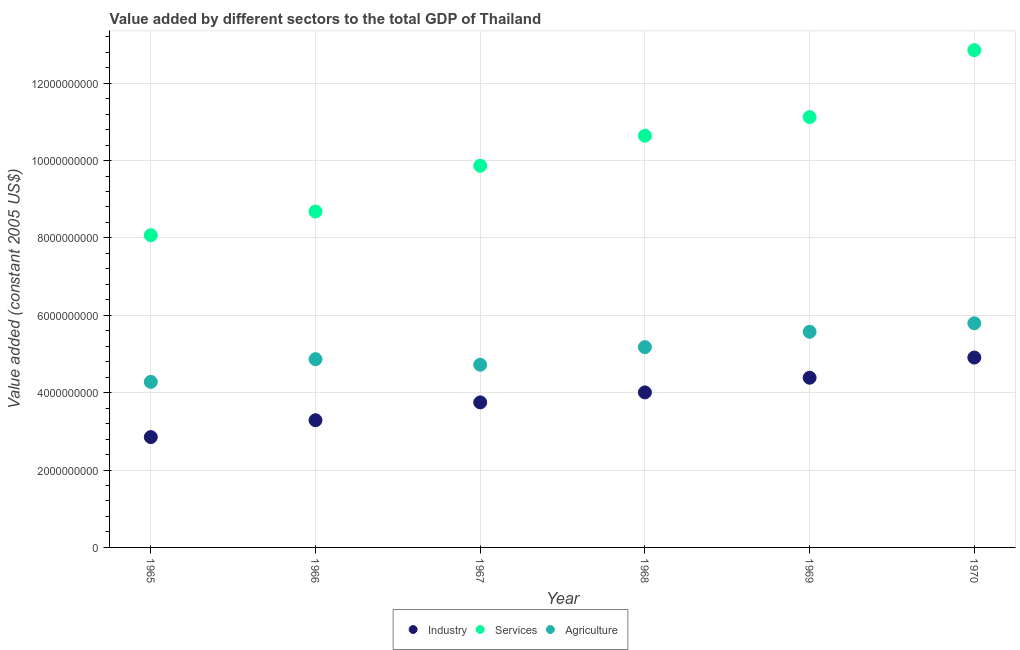How many different coloured dotlines are there?
Give a very brief answer. 3. What is the value added by services in 1967?
Your answer should be compact. 9.87e+09. Across all years, what is the maximum value added by industrial sector?
Provide a short and direct response. 4.91e+09. Across all years, what is the minimum value added by services?
Keep it short and to the point. 8.07e+09. In which year was the value added by industrial sector minimum?
Provide a short and direct response. 1965. What is the total value added by services in the graph?
Offer a very short reply. 6.12e+1. What is the difference between the value added by services in 1965 and that in 1969?
Keep it short and to the point. -3.05e+09. What is the difference between the value added by services in 1966 and the value added by industrial sector in 1969?
Make the answer very short. 4.30e+09. What is the average value added by industrial sector per year?
Offer a terse response. 3.86e+09. In the year 1969, what is the difference between the value added by industrial sector and value added by services?
Make the answer very short. -6.74e+09. What is the ratio of the value added by services in 1966 to that in 1970?
Provide a short and direct response. 0.68. Is the value added by industrial sector in 1965 less than that in 1970?
Offer a very short reply. Yes. Is the difference between the value added by services in 1966 and 1967 greater than the difference between the value added by industrial sector in 1966 and 1967?
Keep it short and to the point. No. What is the difference between the highest and the second highest value added by industrial sector?
Make the answer very short. 5.22e+08. What is the difference between the highest and the lowest value added by agricultural sector?
Make the answer very short. 1.52e+09. Does the value added by industrial sector monotonically increase over the years?
Your response must be concise. Yes. Is the value added by agricultural sector strictly greater than the value added by services over the years?
Your answer should be compact. No. Is the value added by services strictly less than the value added by industrial sector over the years?
Ensure brevity in your answer.  No. How many dotlines are there?
Provide a short and direct response. 3. Does the graph contain any zero values?
Your response must be concise. No. How many legend labels are there?
Make the answer very short. 3. How are the legend labels stacked?
Keep it short and to the point. Horizontal. What is the title of the graph?
Your answer should be very brief. Value added by different sectors to the total GDP of Thailand. Does "Textiles and clothing" appear as one of the legend labels in the graph?
Offer a very short reply. No. What is the label or title of the X-axis?
Your answer should be very brief. Year. What is the label or title of the Y-axis?
Provide a succinct answer. Value added (constant 2005 US$). What is the Value added (constant 2005 US$) in Industry in 1965?
Your answer should be compact. 2.85e+09. What is the Value added (constant 2005 US$) of Services in 1965?
Offer a terse response. 8.07e+09. What is the Value added (constant 2005 US$) in Agriculture in 1965?
Your answer should be compact. 4.28e+09. What is the Value added (constant 2005 US$) in Industry in 1966?
Your answer should be very brief. 3.29e+09. What is the Value added (constant 2005 US$) in Services in 1966?
Your answer should be very brief. 8.68e+09. What is the Value added (constant 2005 US$) of Agriculture in 1966?
Keep it short and to the point. 4.87e+09. What is the Value added (constant 2005 US$) of Industry in 1967?
Your response must be concise. 3.75e+09. What is the Value added (constant 2005 US$) of Services in 1967?
Ensure brevity in your answer.  9.87e+09. What is the Value added (constant 2005 US$) in Agriculture in 1967?
Offer a terse response. 4.72e+09. What is the Value added (constant 2005 US$) in Industry in 1968?
Offer a very short reply. 4.01e+09. What is the Value added (constant 2005 US$) in Services in 1968?
Your answer should be very brief. 1.06e+1. What is the Value added (constant 2005 US$) of Agriculture in 1968?
Your answer should be compact. 5.18e+09. What is the Value added (constant 2005 US$) of Industry in 1969?
Ensure brevity in your answer.  4.39e+09. What is the Value added (constant 2005 US$) of Services in 1969?
Your answer should be very brief. 1.11e+1. What is the Value added (constant 2005 US$) in Agriculture in 1969?
Your response must be concise. 5.57e+09. What is the Value added (constant 2005 US$) in Industry in 1970?
Provide a succinct answer. 4.91e+09. What is the Value added (constant 2005 US$) in Services in 1970?
Your answer should be compact. 1.29e+1. What is the Value added (constant 2005 US$) of Agriculture in 1970?
Give a very brief answer. 5.79e+09. Across all years, what is the maximum Value added (constant 2005 US$) in Industry?
Your response must be concise. 4.91e+09. Across all years, what is the maximum Value added (constant 2005 US$) in Services?
Your answer should be compact. 1.29e+1. Across all years, what is the maximum Value added (constant 2005 US$) of Agriculture?
Your response must be concise. 5.79e+09. Across all years, what is the minimum Value added (constant 2005 US$) of Industry?
Ensure brevity in your answer.  2.85e+09. Across all years, what is the minimum Value added (constant 2005 US$) of Services?
Provide a short and direct response. 8.07e+09. Across all years, what is the minimum Value added (constant 2005 US$) of Agriculture?
Provide a short and direct response. 4.28e+09. What is the total Value added (constant 2005 US$) in Industry in the graph?
Your answer should be compact. 2.32e+1. What is the total Value added (constant 2005 US$) of Services in the graph?
Your answer should be very brief. 6.12e+1. What is the total Value added (constant 2005 US$) of Agriculture in the graph?
Your response must be concise. 3.04e+1. What is the difference between the Value added (constant 2005 US$) of Industry in 1965 and that in 1966?
Your answer should be compact. -4.35e+08. What is the difference between the Value added (constant 2005 US$) of Services in 1965 and that in 1966?
Offer a very short reply. -6.14e+08. What is the difference between the Value added (constant 2005 US$) of Agriculture in 1965 and that in 1966?
Your answer should be very brief. -5.87e+08. What is the difference between the Value added (constant 2005 US$) of Industry in 1965 and that in 1967?
Provide a short and direct response. -8.96e+08. What is the difference between the Value added (constant 2005 US$) in Services in 1965 and that in 1967?
Provide a succinct answer. -1.80e+09. What is the difference between the Value added (constant 2005 US$) in Agriculture in 1965 and that in 1967?
Offer a very short reply. -4.43e+08. What is the difference between the Value added (constant 2005 US$) in Industry in 1965 and that in 1968?
Make the answer very short. -1.15e+09. What is the difference between the Value added (constant 2005 US$) in Services in 1965 and that in 1968?
Your answer should be compact. -2.57e+09. What is the difference between the Value added (constant 2005 US$) in Agriculture in 1965 and that in 1968?
Give a very brief answer. -8.99e+08. What is the difference between the Value added (constant 2005 US$) of Industry in 1965 and that in 1969?
Keep it short and to the point. -1.53e+09. What is the difference between the Value added (constant 2005 US$) of Services in 1965 and that in 1969?
Provide a succinct answer. -3.05e+09. What is the difference between the Value added (constant 2005 US$) in Agriculture in 1965 and that in 1969?
Make the answer very short. -1.29e+09. What is the difference between the Value added (constant 2005 US$) in Industry in 1965 and that in 1970?
Give a very brief answer. -2.06e+09. What is the difference between the Value added (constant 2005 US$) in Services in 1965 and that in 1970?
Offer a terse response. -4.78e+09. What is the difference between the Value added (constant 2005 US$) in Agriculture in 1965 and that in 1970?
Your answer should be compact. -1.52e+09. What is the difference between the Value added (constant 2005 US$) of Industry in 1966 and that in 1967?
Offer a terse response. -4.61e+08. What is the difference between the Value added (constant 2005 US$) in Services in 1966 and that in 1967?
Make the answer very short. -1.18e+09. What is the difference between the Value added (constant 2005 US$) of Agriculture in 1966 and that in 1967?
Your response must be concise. 1.44e+08. What is the difference between the Value added (constant 2005 US$) of Industry in 1966 and that in 1968?
Your response must be concise. -7.19e+08. What is the difference between the Value added (constant 2005 US$) in Services in 1966 and that in 1968?
Offer a very short reply. -1.96e+09. What is the difference between the Value added (constant 2005 US$) of Agriculture in 1966 and that in 1968?
Your answer should be very brief. -3.12e+08. What is the difference between the Value added (constant 2005 US$) of Industry in 1966 and that in 1969?
Keep it short and to the point. -1.10e+09. What is the difference between the Value added (constant 2005 US$) of Services in 1966 and that in 1969?
Make the answer very short. -2.44e+09. What is the difference between the Value added (constant 2005 US$) of Agriculture in 1966 and that in 1969?
Provide a short and direct response. -7.07e+08. What is the difference between the Value added (constant 2005 US$) in Industry in 1966 and that in 1970?
Provide a succinct answer. -1.62e+09. What is the difference between the Value added (constant 2005 US$) in Services in 1966 and that in 1970?
Your answer should be compact. -4.17e+09. What is the difference between the Value added (constant 2005 US$) of Agriculture in 1966 and that in 1970?
Provide a succinct answer. -9.28e+08. What is the difference between the Value added (constant 2005 US$) in Industry in 1967 and that in 1968?
Make the answer very short. -2.58e+08. What is the difference between the Value added (constant 2005 US$) in Services in 1967 and that in 1968?
Provide a short and direct response. -7.76e+08. What is the difference between the Value added (constant 2005 US$) of Agriculture in 1967 and that in 1968?
Your response must be concise. -4.55e+08. What is the difference between the Value added (constant 2005 US$) in Industry in 1967 and that in 1969?
Give a very brief answer. -6.37e+08. What is the difference between the Value added (constant 2005 US$) in Services in 1967 and that in 1969?
Provide a short and direct response. -1.26e+09. What is the difference between the Value added (constant 2005 US$) of Agriculture in 1967 and that in 1969?
Your answer should be compact. -8.51e+08. What is the difference between the Value added (constant 2005 US$) in Industry in 1967 and that in 1970?
Make the answer very short. -1.16e+09. What is the difference between the Value added (constant 2005 US$) in Services in 1967 and that in 1970?
Offer a very short reply. -2.99e+09. What is the difference between the Value added (constant 2005 US$) of Agriculture in 1967 and that in 1970?
Your response must be concise. -1.07e+09. What is the difference between the Value added (constant 2005 US$) of Industry in 1968 and that in 1969?
Provide a succinct answer. -3.79e+08. What is the difference between the Value added (constant 2005 US$) in Services in 1968 and that in 1969?
Keep it short and to the point. -4.81e+08. What is the difference between the Value added (constant 2005 US$) of Agriculture in 1968 and that in 1969?
Keep it short and to the point. -3.95e+08. What is the difference between the Value added (constant 2005 US$) of Industry in 1968 and that in 1970?
Give a very brief answer. -9.01e+08. What is the difference between the Value added (constant 2005 US$) of Services in 1968 and that in 1970?
Offer a terse response. -2.21e+09. What is the difference between the Value added (constant 2005 US$) of Agriculture in 1968 and that in 1970?
Your response must be concise. -6.16e+08. What is the difference between the Value added (constant 2005 US$) in Industry in 1969 and that in 1970?
Your answer should be very brief. -5.22e+08. What is the difference between the Value added (constant 2005 US$) of Services in 1969 and that in 1970?
Give a very brief answer. -1.73e+09. What is the difference between the Value added (constant 2005 US$) of Agriculture in 1969 and that in 1970?
Give a very brief answer. -2.21e+08. What is the difference between the Value added (constant 2005 US$) in Industry in 1965 and the Value added (constant 2005 US$) in Services in 1966?
Offer a terse response. -5.83e+09. What is the difference between the Value added (constant 2005 US$) in Industry in 1965 and the Value added (constant 2005 US$) in Agriculture in 1966?
Make the answer very short. -2.01e+09. What is the difference between the Value added (constant 2005 US$) of Services in 1965 and the Value added (constant 2005 US$) of Agriculture in 1966?
Your answer should be compact. 3.20e+09. What is the difference between the Value added (constant 2005 US$) of Industry in 1965 and the Value added (constant 2005 US$) of Services in 1967?
Provide a short and direct response. -7.01e+09. What is the difference between the Value added (constant 2005 US$) in Industry in 1965 and the Value added (constant 2005 US$) in Agriculture in 1967?
Provide a short and direct response. -1.87e+09. What is the difference between the Value added (constant 2005 US$) of Services in 1965 and the Value added (constant 2005 US$) of Agriculture in 1967?
Keep it short and to the point. 3.35e+09. What is the difference between the Value added (constant 2005 US$) of Industry in 1965 and the Value added (constant 2005 US$) of Services in 1968?
Offer a very short reply. -7.79e+09. What is the difference between the Value added (constant 2005 US$) of Industry in 1965 and the Value added (constant 2005 US$) of Agriculture in 1968?
Keep it short and to the point. -2.33e+09. What is the difference between the Value added (constant 2005 US$) in Services in 1965 and the Value added (constant 2005 US$) in Agriculture in 1968?
Your answer should be very brief. 2.89e+09. What is the difference between the Value added (constant 2005 US$) in Industry in 1965 and the Value added (constant 2005 US$) in Services in 1969?
Give a very brief answer. -8.27e+09. What is the difference between the Value added (constant 2005 US$) in Industry in 1965 and the Value added (constant 2005 US$) in Agriculture in 1969?
Your answer should be compact. -2.72e+09. What is the difference between the Value added (constant 2005 US$) in Services in 1965 and the Value added (constant 2005 US$) in Agriculture in 1969?
Provide a succinct answer. 2.50e+09. What is the difference between the Value added (constant 2005 US$) of Industry in 1965 and the Value added (constant 2005 US$) of Services in 1970?
Provide a short and direct response. -1.00e+1. What is the difference between the Value added (constant 2005 US$) of Industry in 1965 and the Value added (constant 2005 US$) of Agriculture in 1970?
Make the answer very short. -2.94e+09. What is the difference between the Value added (constant 2005 US$) of Services in 1965 and the Value added (constant 2005 US$) of Agriculture in 1970?
Keep it short and to the point. 2.27e+09. What is the difference between the Value added (constant 2005 US$) in Industry in 1966 and the Value added (constant 2005 US$) in Services in 1967?
Make the answer very short. -6.58e+09. What is the difference between the Value added (constant 2005 US$) of Industry in 1966 and the Value added (constant 2005 US$) of Agriculture in 1967?
Your answer should be compact. -1.43e+09. What is the difference between the Value added (constant 2005 US$) of Services in 1966 and the Value added (constant 2005 US$) of Agriculture in 1967?
Offer a very short reply. 3.96e+09. What is the difference between the Value added (constant 2005 US$) in Industry in 1966 and the Value added (constant 2005 US$) in Services in 1968?
Give a very brief answer. -7.35e+09. What is the difference between the Value added (constant 2005 US$) of Industry in 1966 and the Value added (constant 2005 US$) of Agriculture in 1968?
Make the answer very short. -1.89e+09. What is the difference between the Value added (constant 2005 US$) in Services in 1966 and the Value added (constant 2005 US$) in Agriculture in 1968?
Offer a terse response. 3.50e+09. What is the difference between the Value added (constant 2005 US$) in Industry in 1966 and the Value added (constant 2005 US$) in Services in 1969?
Give a very brief answer. -7.83e+09. What is the difference between the Value added (constant 2005 US$) in Industry in 1966 and the Value added (constant 2005 US$) in Agriculture in 1969?
Keep it short and to the point. -2.29e+09. What is the difference between the Value added (constant 2005 US$) of Services in 1966 and the Value added (constant 2005 US$) of Agriculture in 1969?
Offer a very short reply. 3.11e+09. What is the difference between the Value added (constant 2005 US$) of Industry in 1966 and the Value added (constant 2005 US$) of Services in 1970?
Your answer should be very brief. -9.56e+09. What is the difference between the Value added (constant 2005 US$) of Industry in 1966 and the Value added (constant 2005 US$) of Agriculture in 1970?
Your answer should be compact. -2.51e+09. What is the difference between the Value added (constant 2005 US$) of Services in 1966 and the Value added (constant 2005 US$) of Agriculture in 1970?
Your answer should be compact. 2.89e+09. What is the difference between the Value added (constant 2005 US$) in Industry in 1967 and the Value added (constant 2005 US$) in Services in 1968?
Your answer should be very brief. -6.89e+09. What is the difference between the Value added (constant 2005 US$) of Industry in 1967 and the Value added (constant 2005 US$) of Agriculture in 1968?
Provide a short and direct response. -1.43e+09. What is the difference between the Value added (constant 2005 US$) in Services in 1967 and the Value added (constant 2005 US$) in Agriculture in 1968?
Make the answer very short. 4.69e+09. What is the difference between the Value added (constant 2005 US$) in Industry in 1967 and the Value added (constant 2005 US$) in Services in 1969?
Your response must be concise. -7.37e+09. What is the difference between the Value added (constant 2005 US$) in Industry in 1967 and the Value added (constant 2005 US$) in Agriculture in 1969?
Ensure brevity in your answer.  -1.82e+09. What is the difference between the Value added (constant 2005 US$) of Services in 1967 and the Value added (constant 2005 US$) of Agriculture in 1969?
Make the answer very short. 4.29e+09. What is the difference between the Value added (constant 2005 US$) in Industry in 1967 and the Value added (constant 2005 US$) in Services in 1970?
Give a very brief answer. -9.10e+09. What is the difference between the Value added (constant 2005 US$) of Industry in 1967 and the Value added (constant 2005 US$) of Agriculture in 1970?
Offer a very short reply. -2.05e+09. What is the difference between the Value added (constant 2005 US$) in Services in 1967 and the Value added (constant 2005 US$) in Agriculture in 1970?
Offer a terse response. 4.07e+09. What is the difference between the Value added (constant 2005 US$) in Industry in 1968 and the Value added (constant 2005 US$) in Services in 1969?
Your response must be concise. -7.11e+09. What is the difference between the Value added (constant 2005 US$) of Industry in 1968 and the Value added (constant 2005 US$) of Agriculture in 1969?
Provide a succinct answer. -1.57e+09. What is the difference between the Value added (constant 2005 US$) in Services in 1968 and the Value added (constant 2005 US$) in Agriculture in 1969?
Offer a very short reply. 5.07e+09. What is the difference between the Value added (constant 2005 US$) of Industry in 1968 and the Value added (constant 2005 US$) of Services in 1970?
Ensure brevity in your answer.  -8.85e+09. What is the difference between the Value added (constant 2005 US$) of Industry in 1968 and the Value added (constant 2005 US$) of Agriculture in 1970?
Your answer should be very brief. -1.79e+09. What is the difference between the Value added (constant 2005 US$) of Services in 1968 and the Value added (constant 2005 US$) of Agriculture in 1970?
Offer a terse response. 4.85e+09. What is the difference between the Value added (constant 2005 US$) of Industry in 1969 and the Value added (constant 2005 US$) of Services in 1970?
Your answer should be very brief. -8.47e+09. What is the difference between the Value added (constant 2005 US$) of Industry in 1969 and the Value added (constant 2005 US$) of Agriculture in 1970?
Make the answer very short. -1.41e+09. What is the difference between the Value added (constant 2005 US$) of Services in 1969 and the Value added (constant 2005 US$) of Agriculture in 1970?
Offer a terse response. 5.33e+09. What is the average Value added (constant 2005 US$) in Industry per year?
Provide a short and direct response. 3.86e+09. What is the average Value added (constant 2005 US$) in Services per year?
Your answer should be very brief. 1.02e+1. What is the average Value added (constant 2005 US$) in Agriculture per year?
Your response must be concise. 5.07e+09. In the year 1965, what is the difference between the Value added (constant 2005 US$) of Industry and Value added (constant 2005 US$) of Services?
Your answer should be very brief. -5.22e+09. In the year 1965, what is the difference between the Value added (constant 2005 US$) of Industry and Value added (constant 2005 US$) of Agriculture?
Offer a terse response. -1.43e+09. In the year 1965, what is the difference between the Value added (constant 2005 US$) of Services and Value added (constant 2005 US$) of Agriculture?
Make the answer very short. 3.79e+09. In the year 1966, what is the difference between the Value added (constant 2005 US$) of Industry and Value added (constant 2005 US$) of Services?
Provide a short and direct response. -5.39e+09. In the year 1966, what is the difference between the Value added (constant 2005 US$) of Industry and Value added (constant 2005 US$) of Agriculture?
Make the answer very short. -1.58e+09. In the year 1966, what is the difference between the Value added (constant 2005 US$) of Services and Value added (constant 2005 US$) of Agriculture?
Give a very brief answer. 3.82e+09. In the year 1967, what is the difference between the Value added (constant 2005 US$) in Industry and Value added (constant 2005 US$) in Services?
Keep it short and to the point. -6.12e+09. In the year 1967, what is the difference between the Value added (constant 2005 US$) of Industry and Value added (constant 2005 US$) of Agriculture?
Ensure brevity in your answer.  -9.73e+08. In the year 1967, what is the difference between the Value added (constant 2005 US$) in Services and Value added (constant 2005 US$) in Agriculture?
Your response must be concise. 5.14e+09. In the year 1968, what is the difference between the Value added (constant 2005 US$) in Industry and Value added (constant 2005 US$) in Services?
Give a very brief answer. -6.63e+09. In the year 1968, what is the difference between the Value added (constant 2005 US$) of Industry and Value added (constant 2005 US$) of Agriculture?
Your answer should be very brief. -1.17e+09. In the year 1968, what is the difference between the Value added (constant 2005 US$) in Services and Value added (constant 2005 US$) in Agriculture?
Ensure brevity in your answer.  5.46e+09. In the year 1969, what is the difference between the Value added (constant 2005 US$) in Industry and Value added (constant 2005 US$) in Services?
Your answer should be very brief. -6.74e+09. In the year 1969, what is the difference between the Value added (constant 2005 US$) of Industry and Value added (constant 2005 US$) of Agriculture?
Provide a short and direct response. -1.19e+09. In the year 1969, what is the difference between the Value added (constant 2005 US$) in Services and Value added (constant 2005 US$) in Agriculture?
Offer a terse response. 5.55e+09. In the year 1970, what is the difference between the Value added (constant 2005 US$) of Industry and Value added (constant 2005 US$) of Services?
Ensure brevity in your answer.  -7.94e+09. In the year 1970, what is the difference between the Value added (constant 2005 US$) of Industry and Value added (constant 2005 US$) of Agriculture?
Ensure brevity in your answer.  -8.86e+08. In the year 1970, what is the difference between the Value added (constant 2005 US$) of Services and Value added (constant 2005 US$) of Agriculture?
Offer a terse response. 7.06e+09. What is the ratio of the Value added (constant 2005 US$) in Industry in 1965 to that in 1966?
Make the answer very short. 0.87. What is the ratio of the Value added (constant 2005 US$) of Services in 1965 to that in 1966?
Offer a terse response. 0.93. What is the ratio of the Value added (constant 2005 US$) in Agriculture in 1965 to that in 1966?
Give a very brief answer. 0.88. What is the ratio of the Value added (constant 2005 US$) in Industry in 1965 to that in 1967?
Give a very brief answer. 0.76. What is the ratio of the Value added (constant 2005 US$) of Services in 1965 to that in 1967?
Keep it short and to the point. 0.82. What is the ratio of the Value added (constant 2005 US$) in Agriculture in 1965 to that in 1967?
Offer a very short reply. 0.91. What is the ratio of the Value added (constant 2005 US$) in Industry in 1965 to that in 1968?
Make the answer very short. 0.71. What is the ratio of the Value added (constant 2005 US$) of Services in 1965 to that in 1968?
Ensure brevity in your answer.  0.76. What is the ratio of the Value added (constant 2005 US$) in Agriculture in 1965 to that in 1968?
Provide a succinct answer. 0.83. What is the ratio of the Value added (constant 2005 US$) of Industry in 1965 to that in 1969?
Give a very brief answer. 0.65. What is the ratio of the Value added (constant 2005 US$) of Services in 1965 to that in 1969?
Ensure brevity in your answer.  0.73. What is the ratio of the Value added (constant 2005 US$) of Agriculture in 1965 to that in 1969?
Provide a succinct answer. 0.77. What is the ratio of the Value added (constant 2005 US$) in Industry in 1965 to that in 1970?
Your answer should be very brief. 0.58. What is the ratio of the Value added (constant 2005 US$) in Services in 1965 to that in 1970?
Provide a succinct answer. 0.63. What is the ratio of the Value added (constant 2005 US$) of Agriculture in 1965 to that in 1970?
Your response must be concise. 0.74. What is the ratio of the Value added (constant 2005 US$) in Industry in 1966 to that in 1967?
Give a very brief answer. 0.88. What is the ratio of the Value added (constant 2005 US$) of Services in 1966 to that in 1967?
Provide a succinct answer. 0.88. What is the ratio of the Value added (constant 2005 US$) of Agriculture in 1966 to that in 1967?
Make the answer very short. 1.03. What is the ratio of the Value added (constant 2005 US$) in Industry in 1966 to that in 1968?
Give a very brief answer. 0.82. What is the ratio of the Value added (constant 2005 US$) in Services in 1966 to that in 1968?
Your response must be concise. 0.82. What is the ratio of the Value added (constant 2005 US$) of Agriculture in 1966 to that in 1968?
Offer a very short reply. 0.94. What is the ratio of the Value added (constant 2005 US$) in Industry in 1966 to that in 1969?
Offer a very short reply. 0.75. What is the ratio of the Value added (constant 2005 US$) of Services in 1966 to that in 1969?
Your answer should be very brief. 0.78. What is the ratio of the Value added (constant 2005 US$) in Agriculture in 1966 to that in 1969?
Give a very brief answer. 0.87. What is the ratio of the Value added (constant 2005 US$) of Industry in 1966 to that in 1970?
Make the answer very short. 0.67. What is the ratio of the Value added (constant 2005 US$) in Services in 1966 to that in 1970?
Provide a short and direct response. 0.68. What is the ratio of the Value added (constant 2005 US$) of Agriculture in 1966 to that in 1970?
Provide a succinct answer. 0.84. What is the ratio of the Value added (constant 2005 US$) in Industry in 1967 to that in 1968?
Your answer should be very brief. 0.94. What is the ratio of the Value added (constant 2005 US$) in Services in 1967 to that in 1968?
Ensure brevity in your answer.  0.93. What is the ratio of the Value added (constant 2005 US$) in Agriculture in 1967 to that in 1968?
Provide a short and direct response. 0.91. What is the ratio of the Value added (constant 2005 US$) in Industry in 1967 to that in 1969?
Provide a short and direct response. 0.85. What is the ratio of the Value added (constant 2005 US$) in Services in 1967 to that in 1969?
Make the answer very short. 0.89. What is the ratio of the Value added (constant 2005 US$) of Agriculture in 1967 to that in 1969?
Give a very brief answer. 0.85. What is the ratio of the Value added (constant 2005 US$) of Industry in 1967 to that in 1970?
Offer a terse response. 0.76. What is the ratio of the Value added (constant 2005 US$) of Services in 1967 to that in 1970?
Your answer should be very brief. 0.77. What is the ratio of the Value added (constant 2005 US$) in Agriculture in 1967 to that in 1970?
Give a very brief answer. 0.81. What is the ratio of the Value added (constant 2005 US$) of Industry in 1968 to that in 1969?
Offer a very short reply. 0.91. What is the ratio of the Value added (constant 2005 US$) of Services in 1968 to that in 1969?
Offer a terse response. 0.96. What is the ratio of the Value added (constant 2005 US$) in Agriculture in 1968 to that in 1969?
Offer a terse response. 0.93. What is the ratio of the Value added (constant 2005 US$) of Industry in 1968 to that in 1970?
Make the answer very short. 0.82. What is the ratio of the Value added (constant 2005 US$) of Services in 1968 to that in 1970?
Give a very brief answer. 0.83. What is the ratio of the Value added (constant 2005 US$) of Agriculture in 1968 to that in 1970?
Ensure brevity in your answer.  0.89. What is the ratio of the Value added (constant 2005 US$) of Industry in 1969 to that in 1970?
Keep it short and to the point. 0.89. What is the ratio of the Value added (constant 2005 US$) in Services in 1969 to that in 1970?
Give a very brief answer. 0.87. What is the ratio of the Value added (constant 2005 US$) of Agriculture in 1969 to that in 1970?
Provide a short and direct response. 0.96. What is the difference between the highest and the second highest Value added (constant 2005 US$) of Industry?
Your answer should be very brief. 5.22e+08. What is the difference between the highest and the second highest Value added (constant 2005 US$) of Services?
Your answer should be very brief. 1.73e+09. What is the difference between the highest and the second highest Value added (constant 2005 US$) of Agriculture?
Ensure brevity in your answer.  2.21e+08. What is the difference between the highest and the lowest Value added (constant 2005 US$) in Industry?
Provide a succinct answer. 2.06e+09. What is the difference between the highest and the lowest Value added (constant 2005 US$) of Services?
Your answer should be compact. 4.78e+09. What is the difference between the highest and the lowest Value added (constant 2005 US$) of Agriculture?
Your answer should be compact. 1.52e+09. 